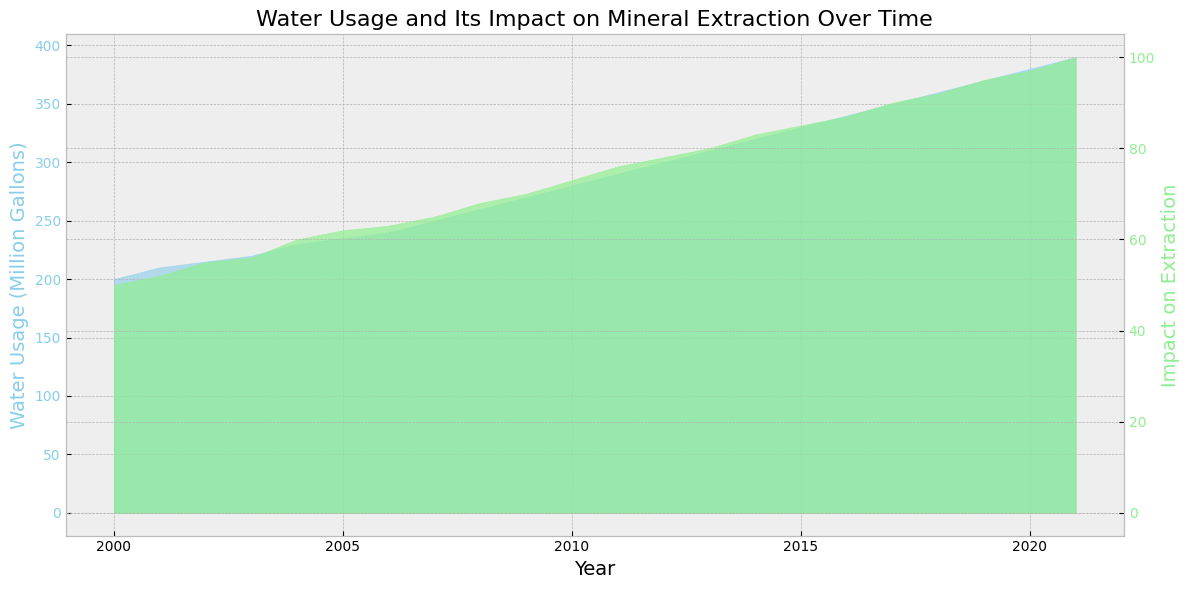What is the general trend of water usage over the years? The area chart with "Water Usage (Million Gallons)" in sky blue shows a steadily increasing trend from 2000 to 2021. As the years progress, the water usage consistently rises.
Answer: Increasing During which year did water usage first reach 300 million gallons? By examining the sky blue area in the chart, the water usage first reaches 300 million gallons in the year 2012.
Answer: 2012 Do both water usage and its impact on extraction show a similar trend? Both the sky blue (water usage) and light green (impact on extraction) areas show a steadily increasing trend over the years, indicating a similar upward pattern.
Answer: Yes What is the highest value recorded for water usage? The maximum height of the sky blue area represents the highest water usage, which is recorded in the year 2021 with 390 million gallons.
Answer: 390 million gallons Is there any year where the impact on extraction decreases compared to the previous year? The light green area continuously increases each year without any dips or decreases, indicating that the impact on extraction does not decrease in any year.
Answer: No How much did water usage increase from the year 2000 to the year 2021? In 2000, the water usage was 200 million gallons, and it increased to 390 million gallons by 2021. The difference is 390 - 200 = 190 million gallons.
Answer: 190 million gallons What is the impact on extraction when water usage is at 250 million gallons? In the year 2007, the sky blue area shows water usage at 250 million gallons. The corresponding height of the light green area indicates the impact on extraction is 65.
Answer: 65 Which year showed a higher impact on extraction: 2005 or 2015? By comparing the height of the light green areas for the years 2005 and 2015, it is evident that the impact on extraction is higher in 2015 (85) than in 2005 (62).
Answer: 2015 What is the average water usage from 2010 to 2020? From 2010 to 2020, the water usages are 280, 290, 300, 310, 320, 330, 340, 350, 360, and 370 million gallons. Adding these gives 3450. There are 11 years, so the average is 3450 / 11 ≈ 313.64 million gallons.
Answer: 313.64 million gallons By how much did the impact on extraction change from 2008 to 2013? The impact on extraction in 2008 is 68, and in 2013 it is 80. The difference is 80 - 68 = 12.
Answer: 12 